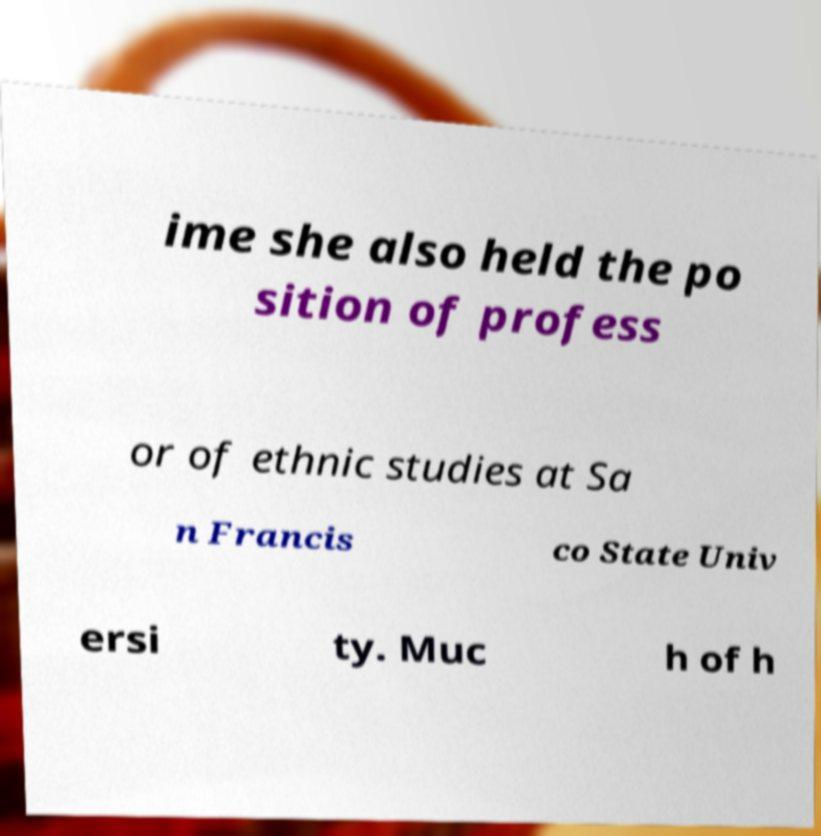Could you assist in decoding the text presented in this image and type it out clearly? ime she also held the po sition of profess or of ethnic studies at Sa n Francis co State Univ ersi ty. Muc h of h 